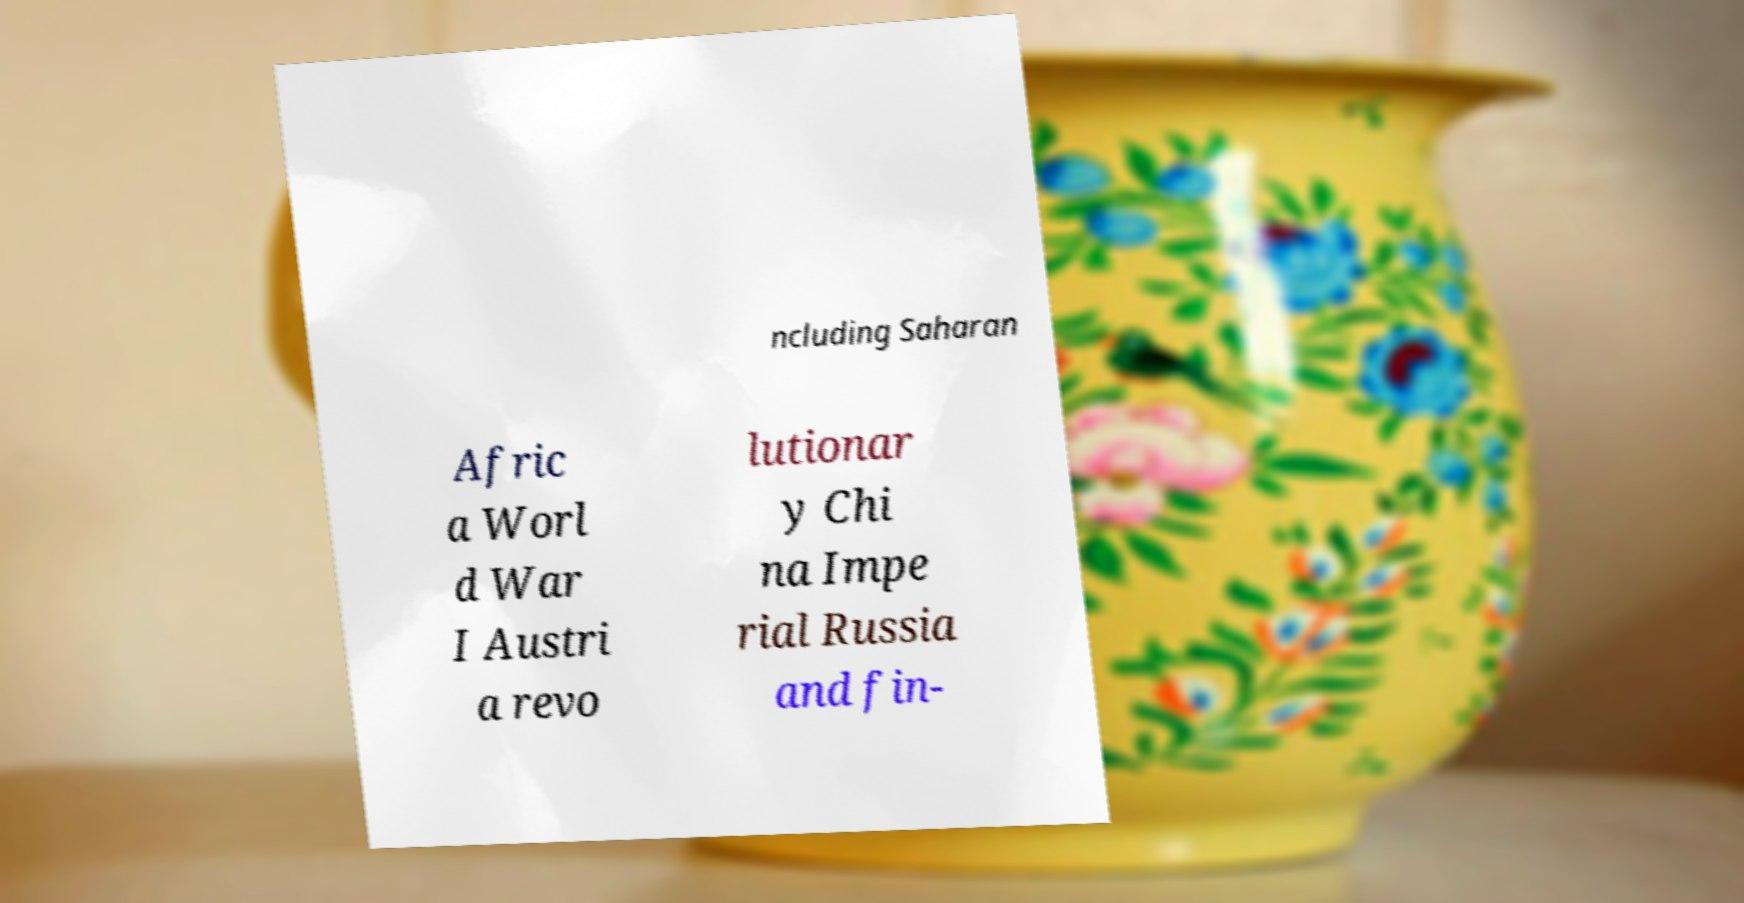Please read and relay the text visible in this image. What does it say? ncluding Saharan Afric a Worl d War I Austri a revo lutionar y Chi na Impe rial Russia and fin- 